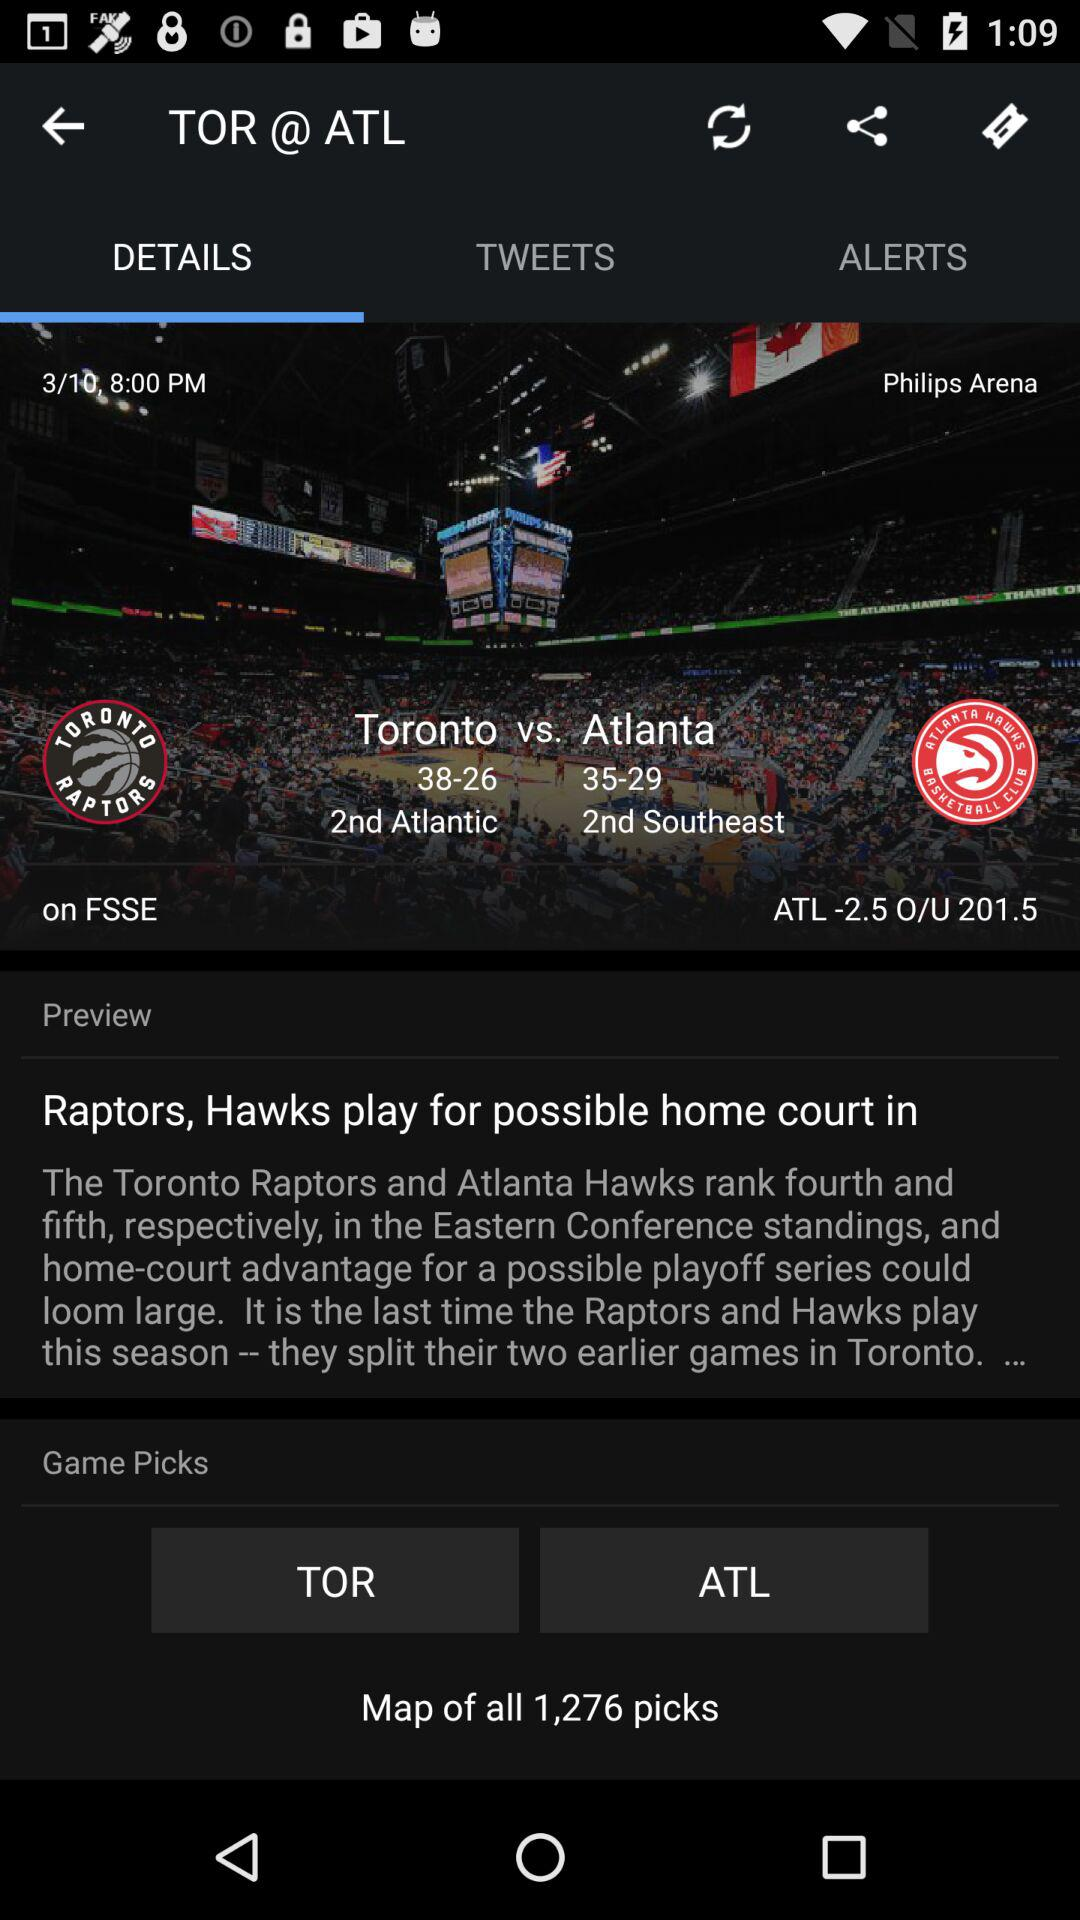What is the arena name? The name is "Philips Arena". 